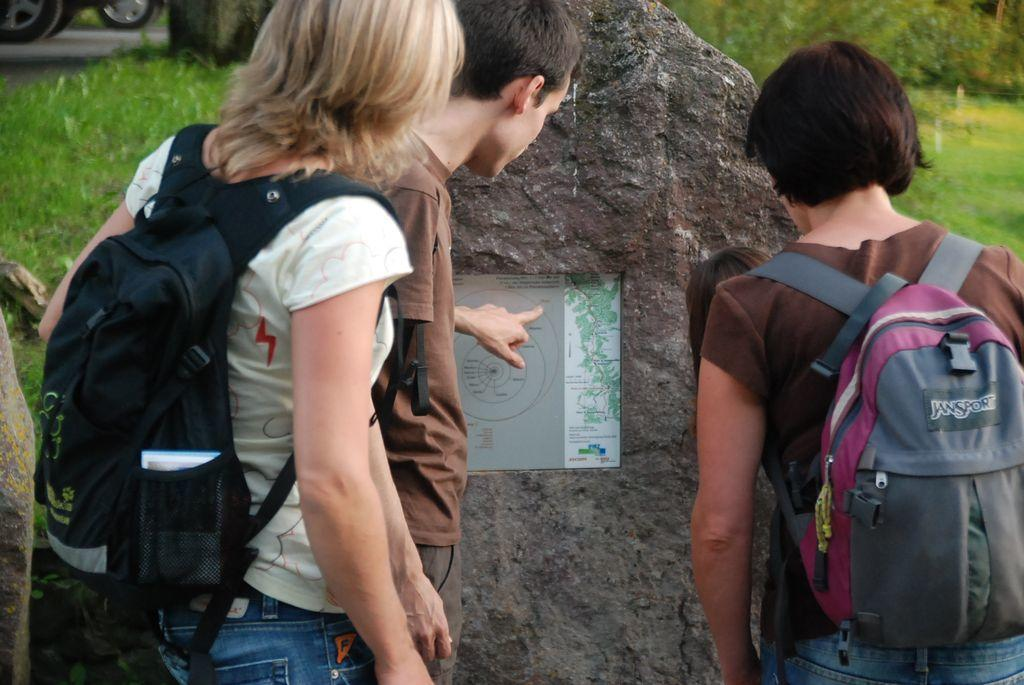<image>
Render a clear and concise summary of the photo. a woman in a JanSport pink and grey backpack looks as her two friends point at a map 